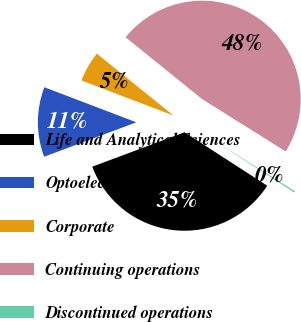<chart> <loc_0><loc_0><loc_500><loc_500><pie_chart><fcel>Life and Analytical Sciences<fcel>Optoelectronics<fcel>Corporate<fcel>Continuing operations<fcel>Discontinued operations<nl><fcel>35.18%<fcel>11.48%<fcel>5.02%<fcel>48.09%<fcel>0.23%<nl></chart> 